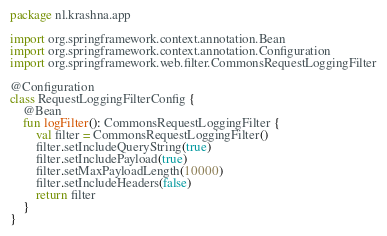<code> <loc_0><loc_0><loc_500><loc_500><_Kotlin_>package nl.krashna.app

import org.springframework.context.annotation.Bean
import org.springframework.context.annotation.Configuration
import org.springframework.web.filter.CommonsRequestLoggingFilter

@Configuration
class RequestLoggingFilterConfig {
    @Bean
    fun logFilter(): CommonsRequestLoggingFilter {
        val filter = CommonsRequestLoggingFilter()
        filter.setIncludeQueryString(true)
        filter.setIncludePayload(true)
        filter.setMaxPayloadLength(10000)
        filter.setIncludeHeaders(false)
        return filter
    }
}
</code> 